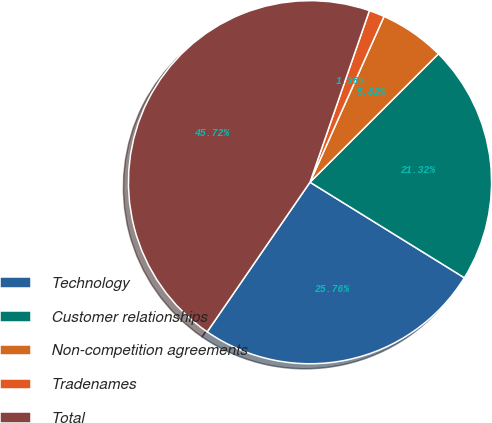Convert chart. <chart><loc_0><loc_0><loc_500><loc_500><pie_chart><fcel>Technology<fcel>Customer relationships<fcel>Non-competition agreements<fcel>Tradenames<fcel>Total<nl><fcel>25.76%<fcel>21.32%<fcel>5.82%<fcel>1.38%<fcel>45.72%<nl></chart> 